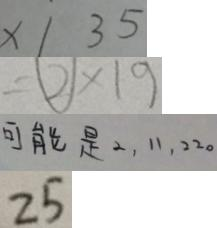<formula> <loc_0><loc_0><loc_500><loc_500>x / 3 5 
 = \textcircled { 2 } \times 1 9 
 可 能 是 2 , 1 1 , 2 2 0 
 2 5</formula> 